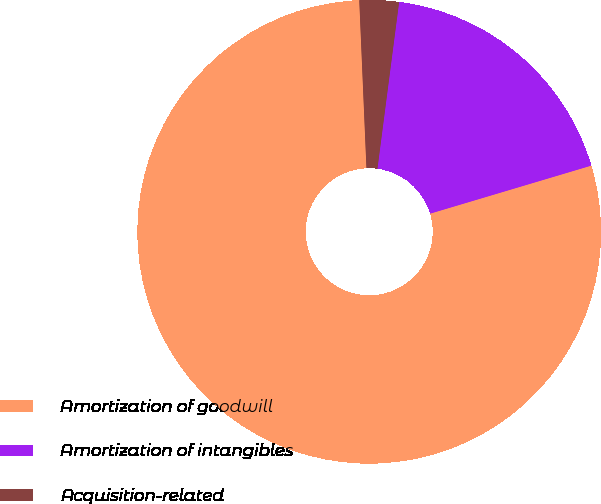Convert chart to OTSL. <chart><loc_0><loc_0><loc_500><loc_500><pie_chart><fcel>Amortization of goodwill<fcel>Amortization of intangibles<fcel>Acquisition-related<nl><fcel>78.93%<fcel>18.33%<fcel>2.74%<nl></chart> 